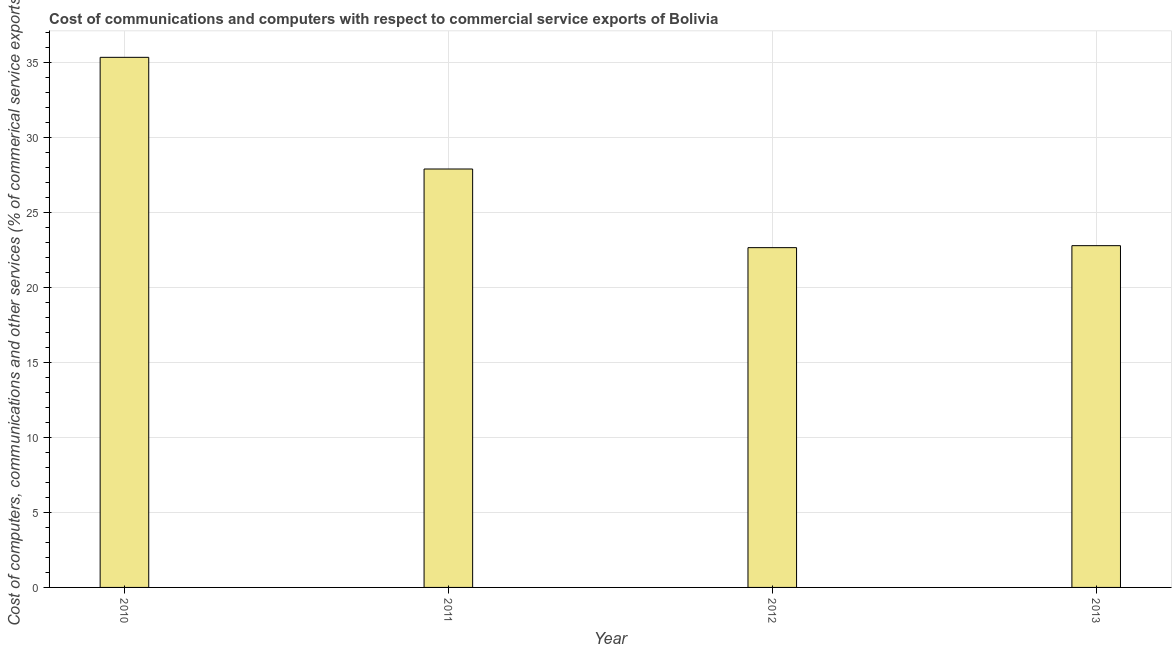What is the title of the graph?
Provide a short and direct response. Cost of communications and computers with respect to commercial service exports of Bolivia. What is the label or title of the X-axis?
Make the answer very short. Year. What is the label or title of the Y-axis?
Offer a very short reply. Cost of computers, communications and other services (% of commerical service exports). What is the  computer and other services in 2013?
Offer a terse response. 22.8. Across all years, what is the maximum  computer and other services?
Your answer should be compact. 35.37. Across all years, what is the minimum cost of communications?
Your response must be concise. 22.67. In which year was the  computer and other services maximum?
Make the answer very short. 2010. What is the sum of the cost of communications?
Provide a succinct answer. 108.75. What is the difference between the cost of communications in 2011 and 2013?
Offer a very short reply. 5.12. What is the average  computer and other services per year?
Offer a terse response. 27.19. What is the median cost of communications?
Your response must be concise. 25.36. Do a majority of the years between 2011 and 2013 (inclusive) have cost of communications greater than 25 %?
Your answer should be very brief. No. What is the ratio of the cost of communications in 2011 to that in 2013?
Offer a very short reply. 1.22. Is the  computer and other services in 2010 less than that in 2012?
Offer a very short reply. No. What is the difference between the highest and the second highest cost of communications?
Offer a terse response. 7.45. What is the Cost of computers, communications and other services (% of commerical service exports) of 2010?
Provide a short and direct response. 35.37. What is the Cost of computers, communications and other services (% of commerical service exports) of 2011?
Make the answer very short. 27.92. What is the Cost of computers, communications and other services (% of commerical service exports) in 2012?
Ensure brevity in your answer.  22.67. What is the Cost of computers, communications and other services (% of commerical service exports) in 2013?
Provide a succinct answer. 22.8. What is the difference between the Cost of computers, communications and other services (% of commerical service exports) in 2010 and 2011?
Give a very brief answer. 7.45. What is the difference between the Cost of computers, communications and other services (% of commerical service exports) in 2010 and 2012?
Make the answer very short. 12.7. What is the difference between the Cost of computers, communications and other services (% of commerical service exports) in 2010 and 2013?
Your answer should be compact. 12.57. What is the difference between the Cost of computers, communications and other services (% of commerical service exports) in 2011 and 2012?
Make the answer very short. 5.25. What is the difference between the Cost of computers, communications and other services (% of commerical service exports) in 2011 and 2013?
Your answer should be compact. 5.11. What is the difference between the Cost of computers, communications and other services (% of commerical service exports) in 2012 and 2013?
Offer a very short reply. -0.13. What is the ratio of the Cost of computers, communications and other services (% of commerical service exports) in 2010 to that in 2011?
Provide a short and direct response. 1.27. What is the ratio of the Cost of computers, communications and other services (% of commerical service exports) in 2010 to that in 2012?
Provide a succinct answer. 1.56. What is the ratio of the Cost of computers, communications and other services (% of commerical service exports) in 2010 to that in 2013?
Your answer should be compact. 1.55. What is the ratio of the Cost of computers, communications and other services (% of commerical service exports) in 2011 to that in 2012?
Your response must be concise. 1.23. What is the ratio of the Cost of computers, communications and other services (% of commerical service exports) in 2011 to that in 2013?
Your answer should be compact. 1.22. What is the ratio of the Cost of computers, communications and other services (% of commerical service exports) in 2012 to that in 2013?
Your answer should be very brief. 0.99. 